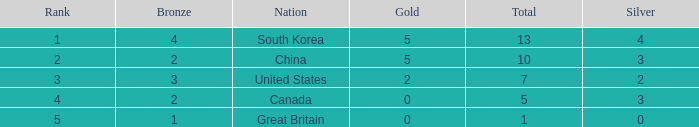What is the lowest Gold, when Nation is Canada, and when Rank is greater than 4? None. 